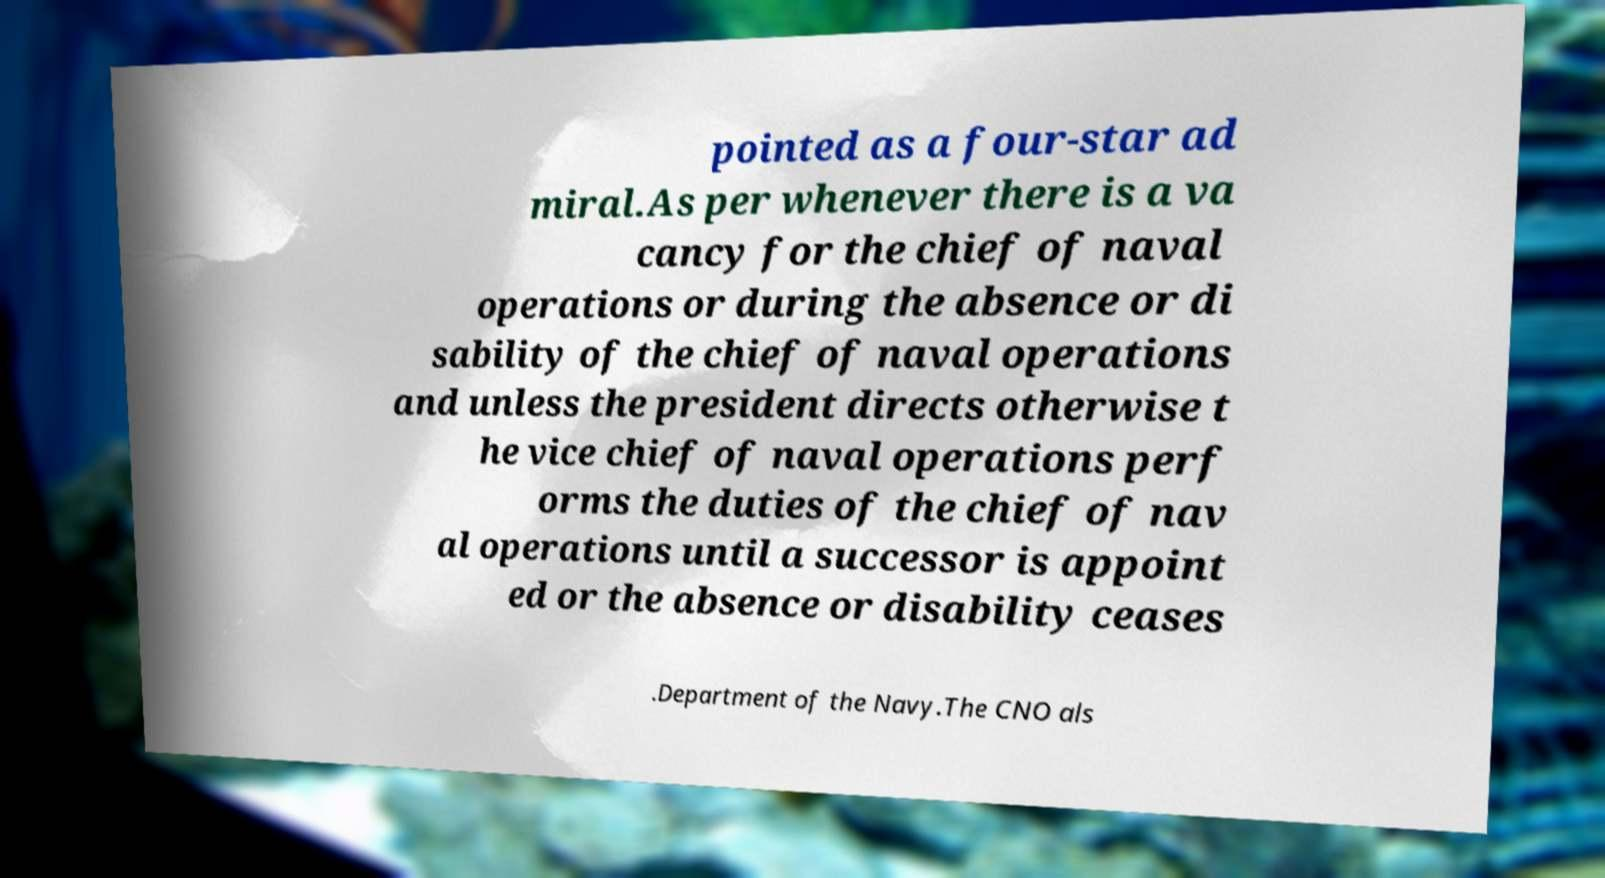Please read and relay the text visible in this image. What does it say? pointed as a four-star ad miral.As per whenever there is a va cancy for the chief of naval operations or during the absence or di sability of the chief of naval operations and unless the president directs otherwise t he vice chief of naval operations perf orms the duties of the chief of nav al operations until a successor is appoint ed or the absence or disability ceases .Department of the Navy.The CNO als 